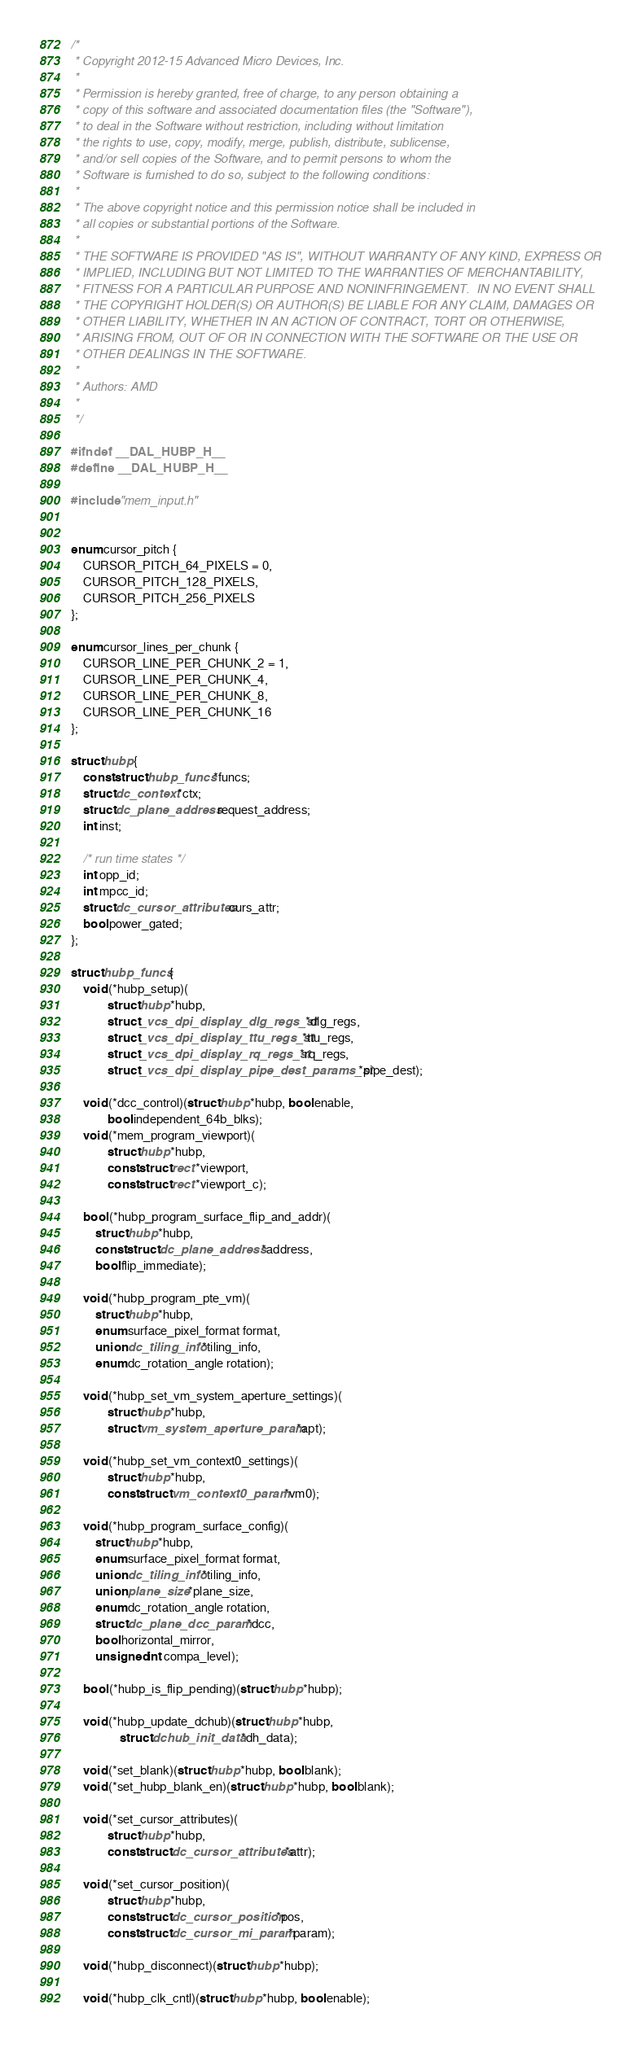<code> <loc_0><loc_0><loc_500><loc_500><_C_>/*
 * Copyright 2012-15 Advanced Micro Devices, Inc.
 *
 * Permission is hereby granted, free of charge, to any person obtaining a
 * copy of this software and associated documentation files (the "Software"),
 * to deal in the Software without restriction, including without limitation
 * the rights to use, copy, modify, merge, publish, distribute, sublicense,
 * and/or sell copies of the Software, and to permit persons to whom the
 * Software is furnished to do so, subject to the following conditions:
 *
 * The above copyright notice and this permission notice shall be included in
 * all copies or substantial portions of the Software.
 *
 * THE SOFTWARE IS PROVIDED "AS IS", WITHOUT WARRANTY OF ANY KIND, EXPRESS OR
 * IMPLIED, INCLUDING BUT NOT LIMITED TO THE WARRANTIES OF MERCHANTABILITY,
 * FITNESS FOR A PARTICULAR PURPOSE AND NONINFRINGEMENT.  IN NO EVENT SHALL
 * THE COPYRIGHT HOLDER(S) OR AUTHOR(S) BE LIABLE FOR ANY CLAIM, DAMAGES OR
 * OTHER LIABILITY, WHETHER IN AN ACTION OF CONTRACT, TORT OR OTHERWISE,
 * ARISING FROM, OUT OF OR IN CONNECTION WITH THE SOFTWARE OR THE USE OR
 * OTHER DEALINGS IN THE SOFTWARE.
 *
 * Authors: AMD
 *
 */

#ifndef __DAL_HUBP_H__
#define __DAL_HUBP_H__

#include "mem_input.h"


enum cursor_pitch {
	CURSOR_PITCH_64_PIXELS = 0,
	CURSOR_PITCH_128_PIXELS,
	CURSOR_PITCH_256_PIXELS
};

enum cursor_lines_per_chunk {
	CURSOR_LINE_PER_CHUNK_2 = 1,
	CURSOR_LINE_PER_CHUNK_4,
	CURSOR_LINE_PER_CHUNK_8,
	CURSOR_LINE_PER_CHUNK_16
};

struct hubp {
	const struct hubp_funcs *funcs;
	struct dc_context *ctx;
	struct dc_plane_address request_address;
	int inst;

	/* run time states */
	int opp_id;
	int mpcc_id;
	struct dc_cursor_attributes curs_attr;
	bool power_gated;
};

struct hubp_funcs {
	void (*hubp_setup)(
			struct hubp *hubp,
			struct _vcs_dpi_display_dlg_regs_st *dlg_regs,
			struct _vcs_dpi_display_ttu_regs_st *ttu_regs,
			struct _vcs_dpi_display_rq_regs_st *rq_regs,
			struct _vcs_dpi_display_pipe_dest_params_st *pipe_dest);

	void (*dcc_control)(struct hubp *hubp, bool enable,
			bool independent_64b_blks);
	void (*mem_program_viewport)(
			struct hubp *hubp,
			const struct rect *viewport,
			const struct rect *viewport_c);

	bool (*hubp_program_surface_flip_and_addr)(
		struct hubp *hubp,
		const struct dc_plane_address *address,
		bool flip_immediate);

	void (*hubp_program_pte_vm)(
		struct hubp *hubp,
		enum surface_pixel_format format,
		union dc_tiling_info *tiling_info,
		enum dc_rotation_angle rotation);

	void (*hubp_set_vm_system_aperture_settings)(
			struct hubp *hubp,
			struct vm_system_aperture_param *apt);

	void (*hubp_set_vm_context0_settings)(
			struct hubp *hubp,
			const struct vm_context0_param *vm0);

	void (*hubp_program_surface_config)(
		struct hubp *hubp,
		enum surface_pixel_format format,
		union dc_tiling_info *tiling_info,
		union plane_size *plane_size,
		enum dc_rotation_angle rotation,
		struct dc_plane_dcc_param *dcc,
		bool horizontal_mirror,
		unsigned int compa_level);

	bool (*hubp_is_flip_pending)(struct hubp *hubp);

	void (*hubp_update_dchub)(struct hubp *hubp,
				struct dchub_init_data *dh_data);

	void (*set_blank)(struct hubp *hubp, bool blank);
	void (*set_hubp_blank_en)(struct hubp *hubp, bool blank);

	void (*set_cursor_attributes)(
			struct hubp *hubp,
			const struct dc_cursor_attributes *attr);

	void (*set_cursor_position)(
			struct hubp *hubp,
			const struct dc_cursor_position *pos,
			const struct dc_cursor_mi_param *param);

	void (*hubp_disconnect)(struct hubp *hubp);

	void (*hubp_clk_cntl)(struct hubp *hubp, bool enable);</code> 